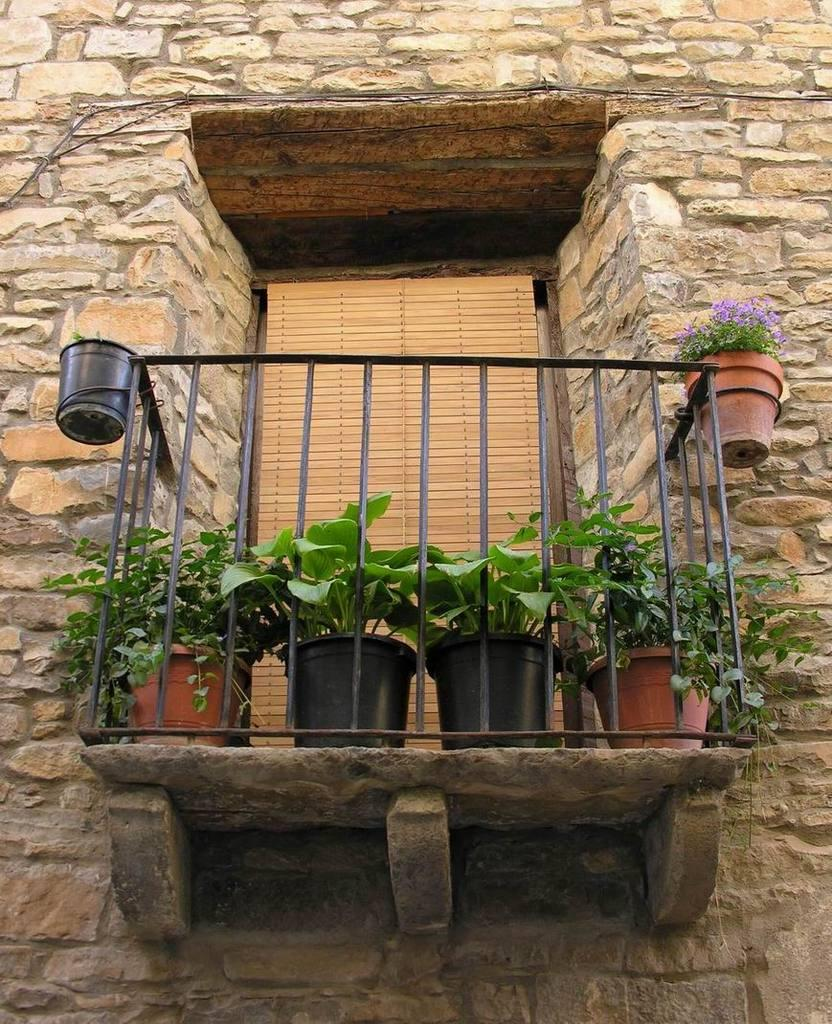What type of plants are visible in the image? There are house plants in the image. What type of architectural feature can be seen in the image? There is railing in the image. What is the background of the image made of? There is a wall in the image. Can you describe any objects present in the image? There are some objects in the image. How many eggs are visible in the image? There are no eggs present in the image. What type of crack is visible on the wall in the image? There is no crack visible on the wall in the image. 